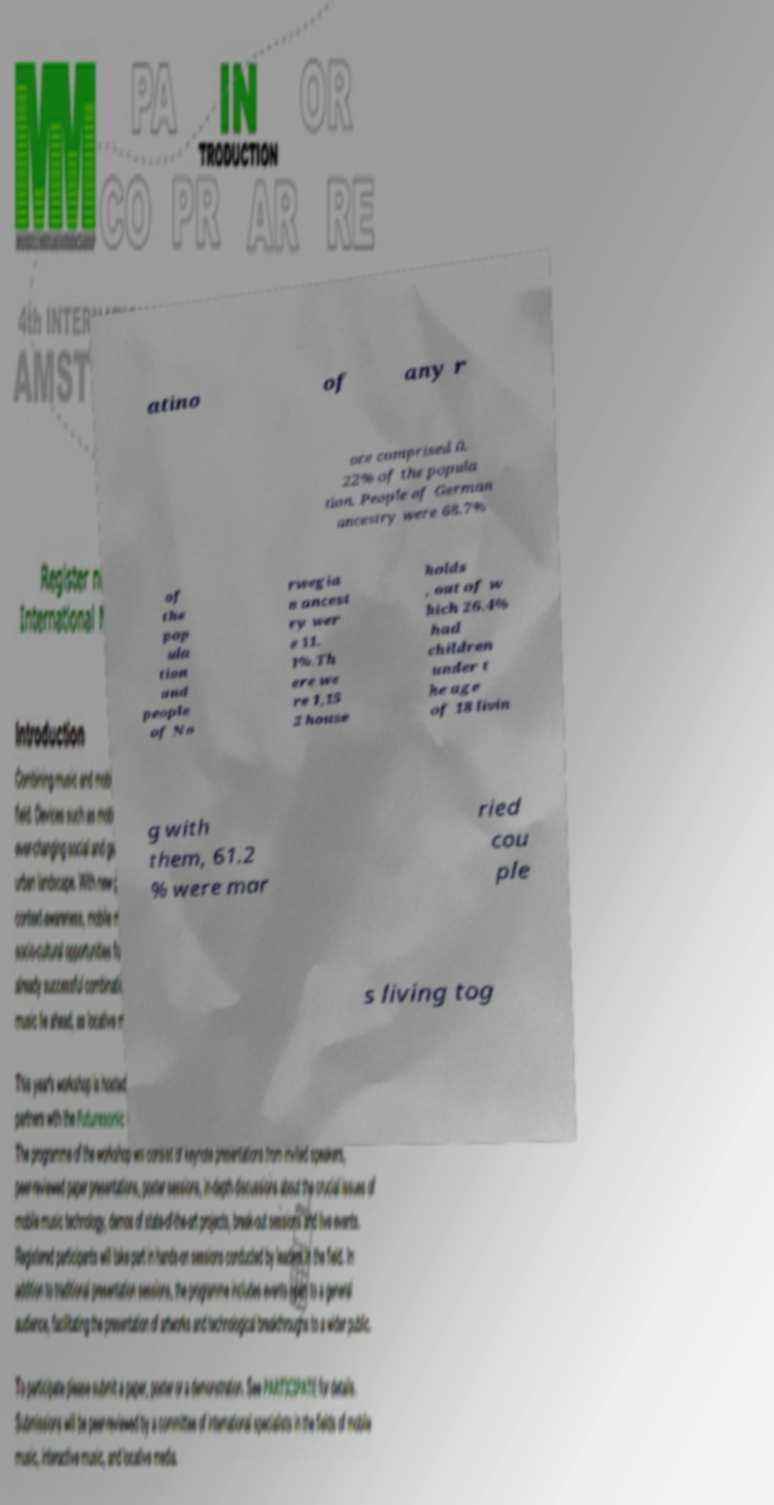What messages or text are displayed in this image? I need them in a readable, typed format. atino of any r ace comprised 0. 22% of the popula tion. People of German ancestry were 68.7% of the pop ula tion and people of No rwegia n ancest ry wer e 11. 1%.Th ere we re 1,15 2 house holds , out of w hich 26.4% had children under t he age of 18 livin g with them, 61.2 % were mar ried cou ple s living tog 